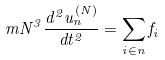<formula> <loc_0><loc_0><loc_500><loc_500>m N ^ { 3 } \frac { d ^ { 2 } { u _ { n } ^ { ( N ) } } } { d t ^ { 2 } } = \sum _ { i \in n } { f _ { i } }</formula> 